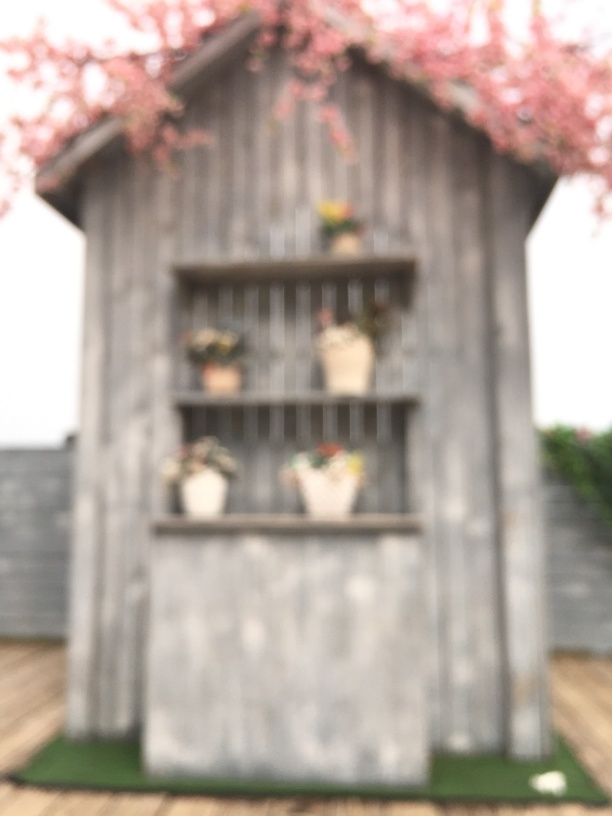Is the blurred effect on the picture intentional and what does it convey? The image appears to have been deliberately taken with a focus that creates a blur effect. This technique can evoke a sense of mystery, memory, or the passage of time, and it often serves to draw attention to the mood or emotional undertone rather than the specific details of the scene. 